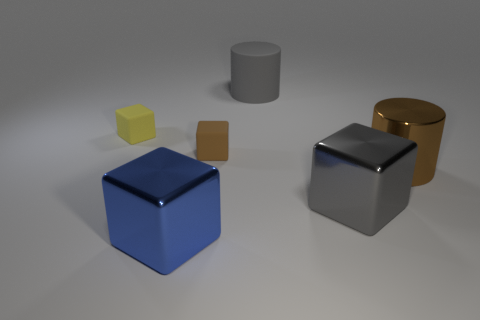Can you describe the lighting and atmosphere of this scene? The scene is softly illuminated with diffused lighting that casts gentle shadows, giving a calm and serene atmosphere. The objects are placed on a simple, matte surface suggesting a neutral, controlled environment possibly intended for focusing on the objects themselves. 
What might be the purpose of arranging these objects like this? This arrangement seems to be composed for a visual study, perhaps to showcase the interplay of shapes, colors, and reflections. It could serve as a demonstration in a 3D modeling software tutorial or as an aesthetically pleasing geometric display. 